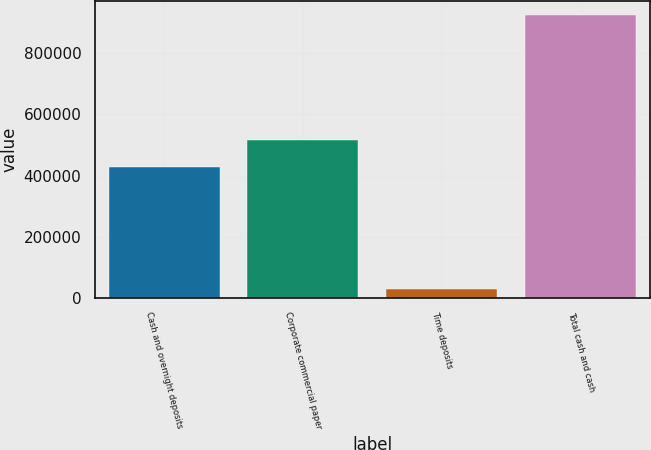<chart> <loc_0><loc_0><loc_500><loc_500><bar_chart><fcel>Cash and overnight deposits<fcel>Corporate commercial paper<fcel>Time deposits<fcel>Total cash and cash<nl><fcel>427307<fcel>516814<fcel>29128<fcel>924195<nl></chart> 